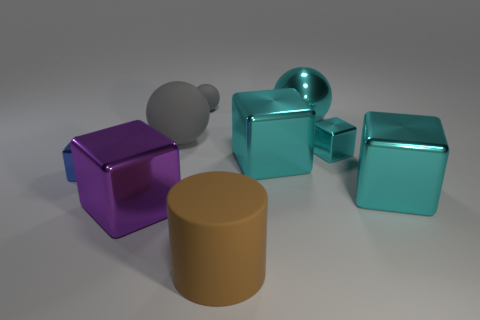What materials could these objects be representing? These objects could represent a mix of materials—metal for the shiny cubes, plastic or clay for the matte cylinder, and glass or polished stone for the sphere due to its semitransparent appearance. 